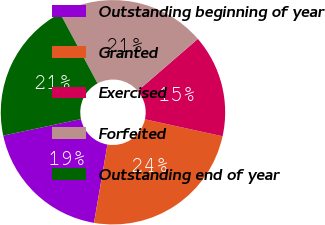<chart> <loc_0><loc_0><loc_500><loc_500><pie_chart><fcel>Outstanding beginning of year<fcel>Granted<fcel>Exercised<fcel>Forfeited<fcel>Outstanding end of year<nl><fcel>18.96%<fcel>24.27%<fcel>14.78%<fcel>21.47%<fcel>20.52%<nl></chart> 